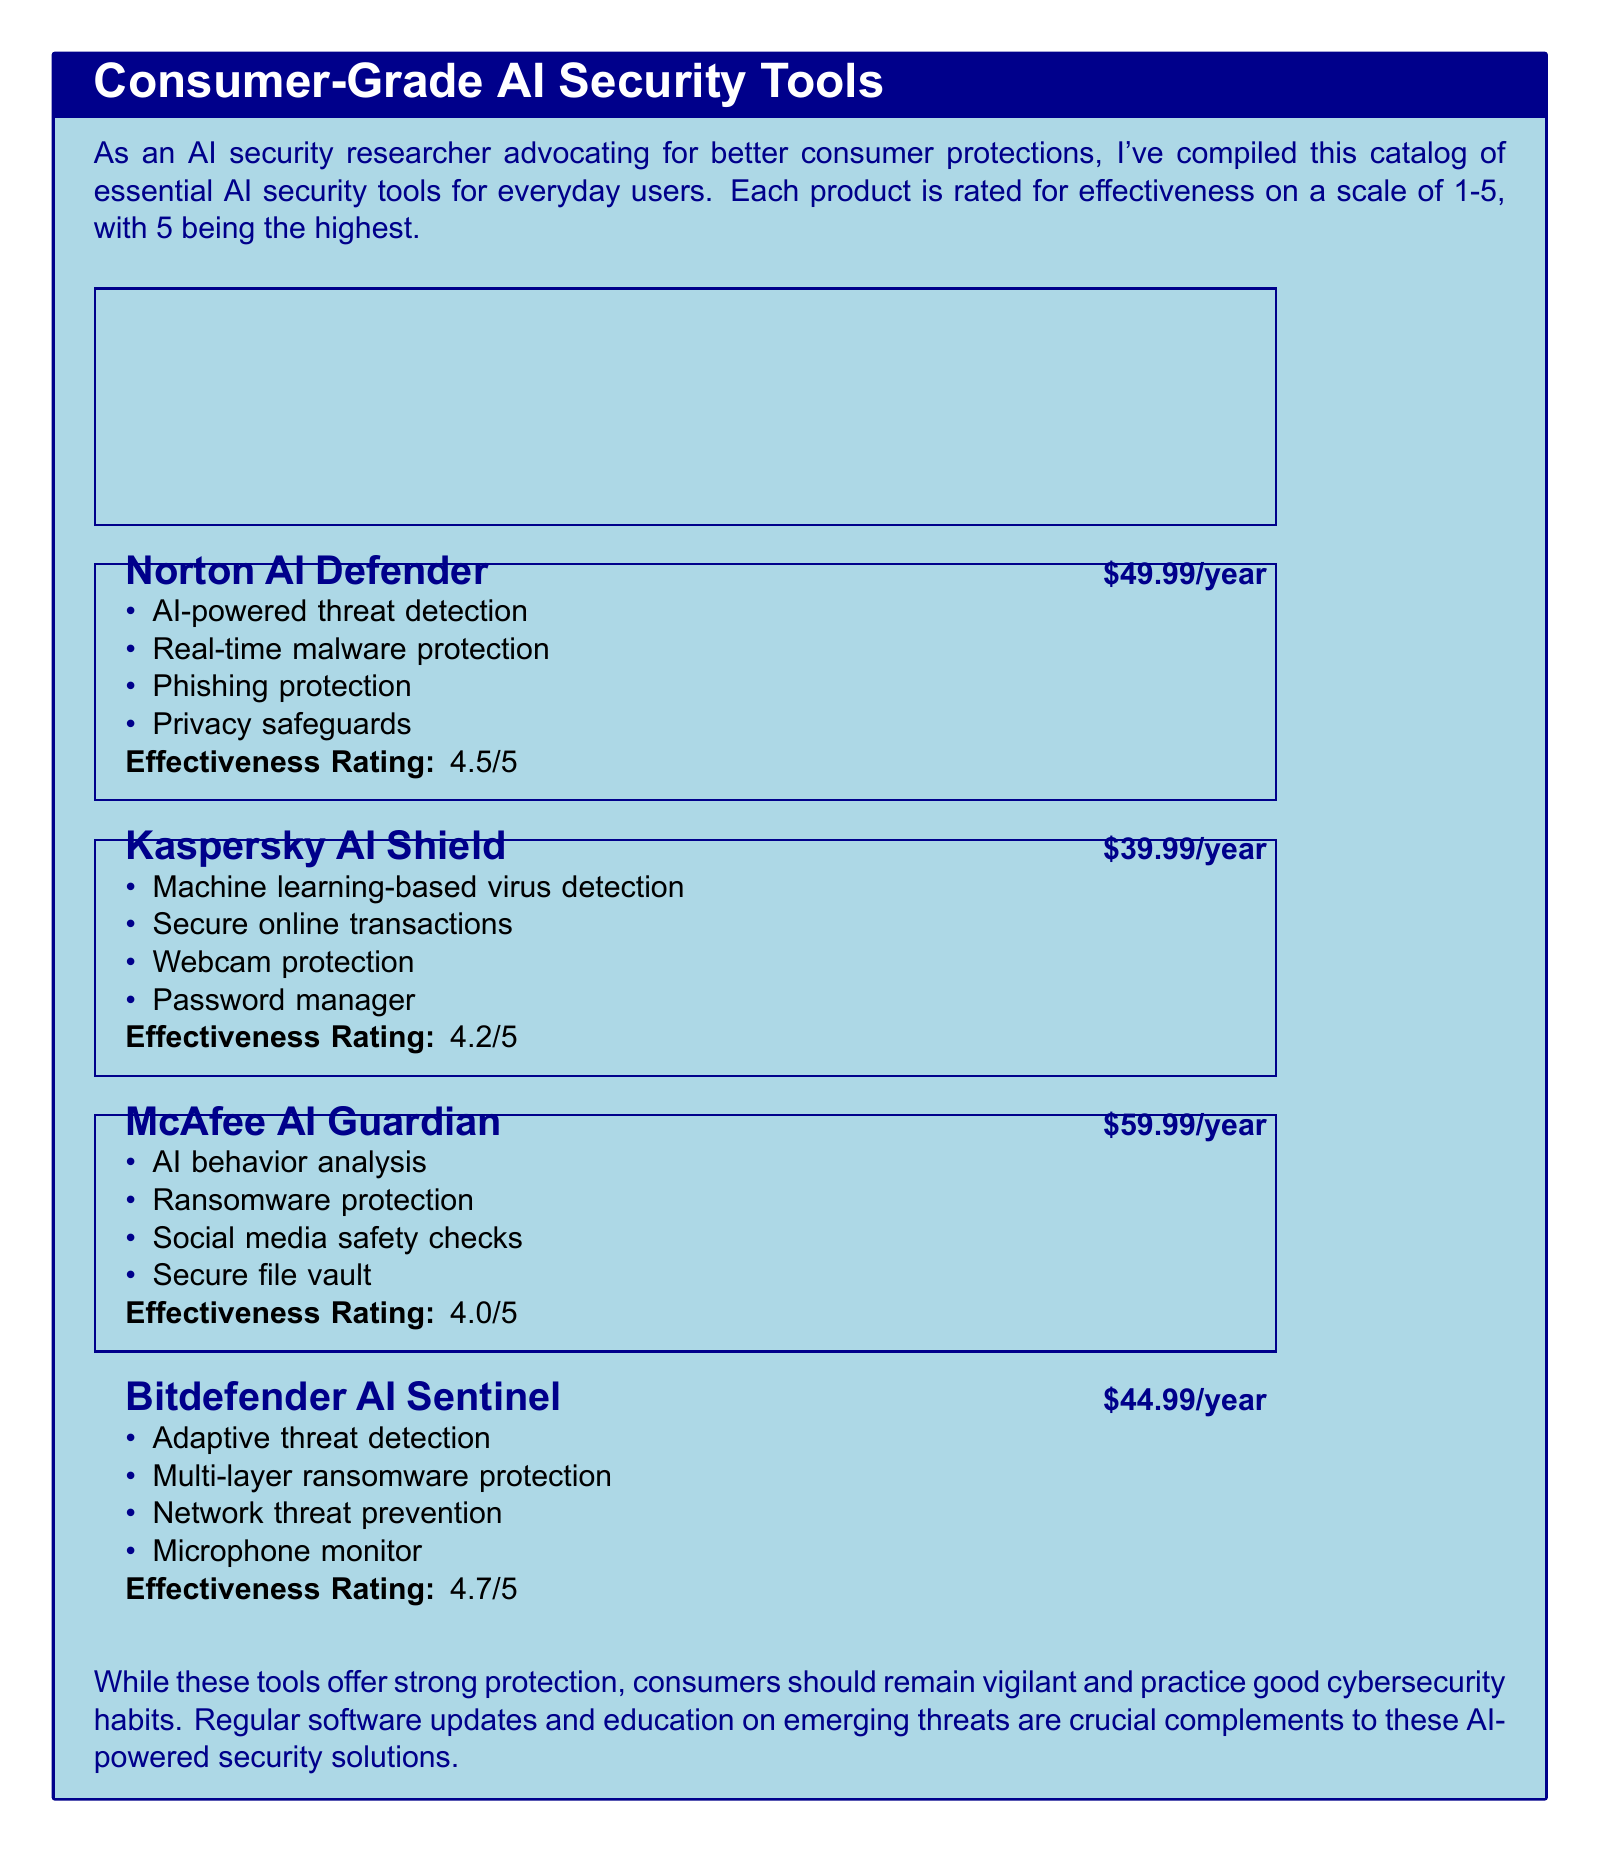What is the price of Norton AI Defender? The price of Norton AI Defender is clearly listed in the document as $49.99/year.
Answer: $49.99/year What feature is unique to Kaspersky AI Shield? The document lists specific features for Kaspersky AI Shield, including webcam protection which is not mentioned for other products.
Answer: Webcam protection What is the effectiveness rating of Bitdefender AI Sentinel? The document provides an effectiveness rating for Bitdefender AI Sentinel, mentioned as 4.7/5.
Answer: 4.7/5 Which product has the highest price? By comparing the prices of all listed products, McAfee AI Guardian is the product with the highest price at $59.99/year.
Answer: $59.99/year How many products are listed in the catalog? The document lists a total of four consumer-grade AI security tools.
Answer: Four What common feature does Norton AI Defender and McAfee AI Guardian both offer? Both products offer malware protection, making it a common feature shared between them.
Answer: Malware protection What is the main theme of the document? The document emphasizes the importance of consumer-grade AI security tools for everyday users, advocating for better consumer protections.
Answer: Consumer-grade AI security tools Which product offers a password manager? The document states that Kaspersky AI Shield includes a password manager as one of its features.
Answer: Kaspersky AI Shield What should consumers practice in addition to using these tools? The document advises that consumers should remain vigilant and practice good cybersecurity habits along with using the tools.
Answer: Cybersecurity habits 